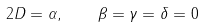<formula> <loc_0><loc_0><loc_500><loc_500>2 D = \alpha , \quad \beta = \gamma = \delta = 0</formula> 